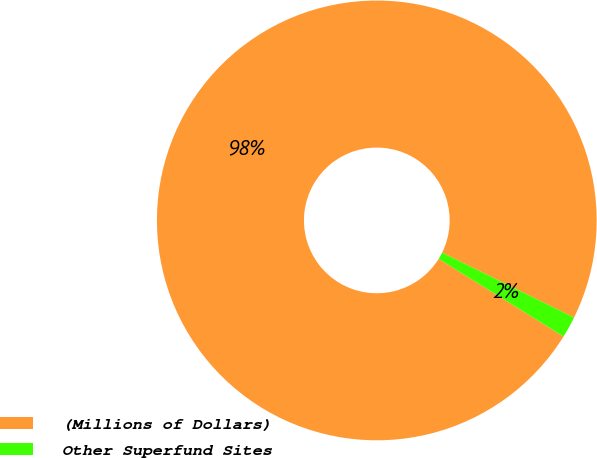Convert chart to OTSL. <chart><loc_0><loc_0><loc_500><loc_500><pie_chart><fcel>(Millions of Dollars)<fcel>Other Superfund Sites<nl><fcel>98.43%<fcel>1.57%<nl></chart> 